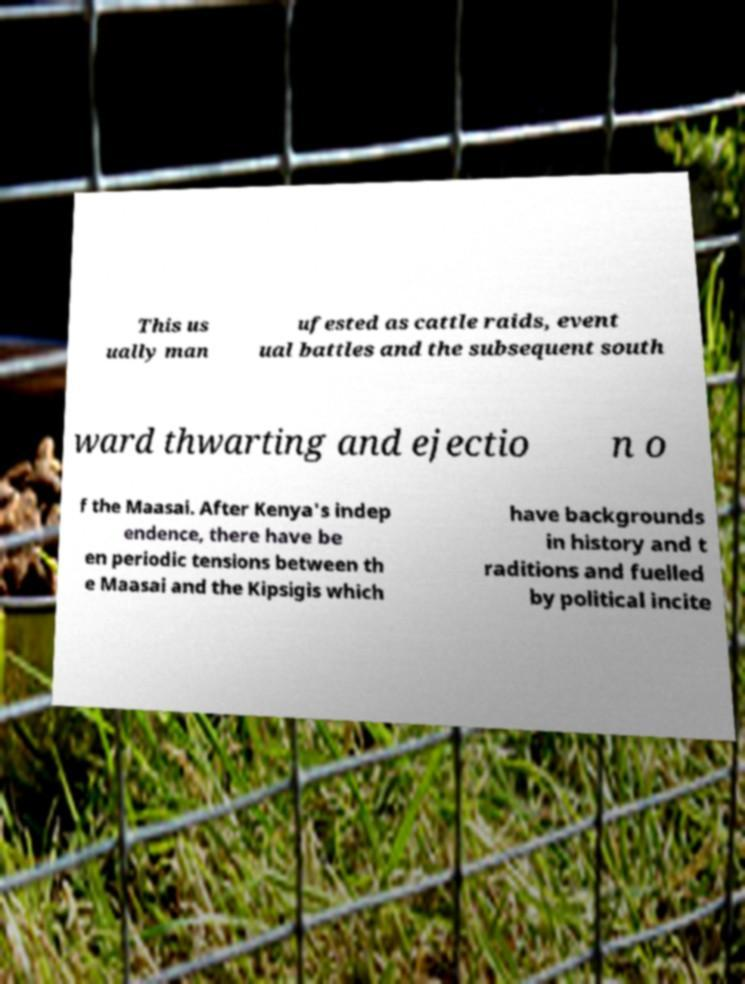Please read and relay the text visible in this image. What does it say? This us ually man ufested as cattle raids, event ual battles and the subsequent south ward thwarting and ejectio n o f the Maasai. After Kenya's indep endence, there have be en periodic tensions between th e Maasai and the Kipsigis which have backgrounds in history and t raditions and fuelled by political incite 